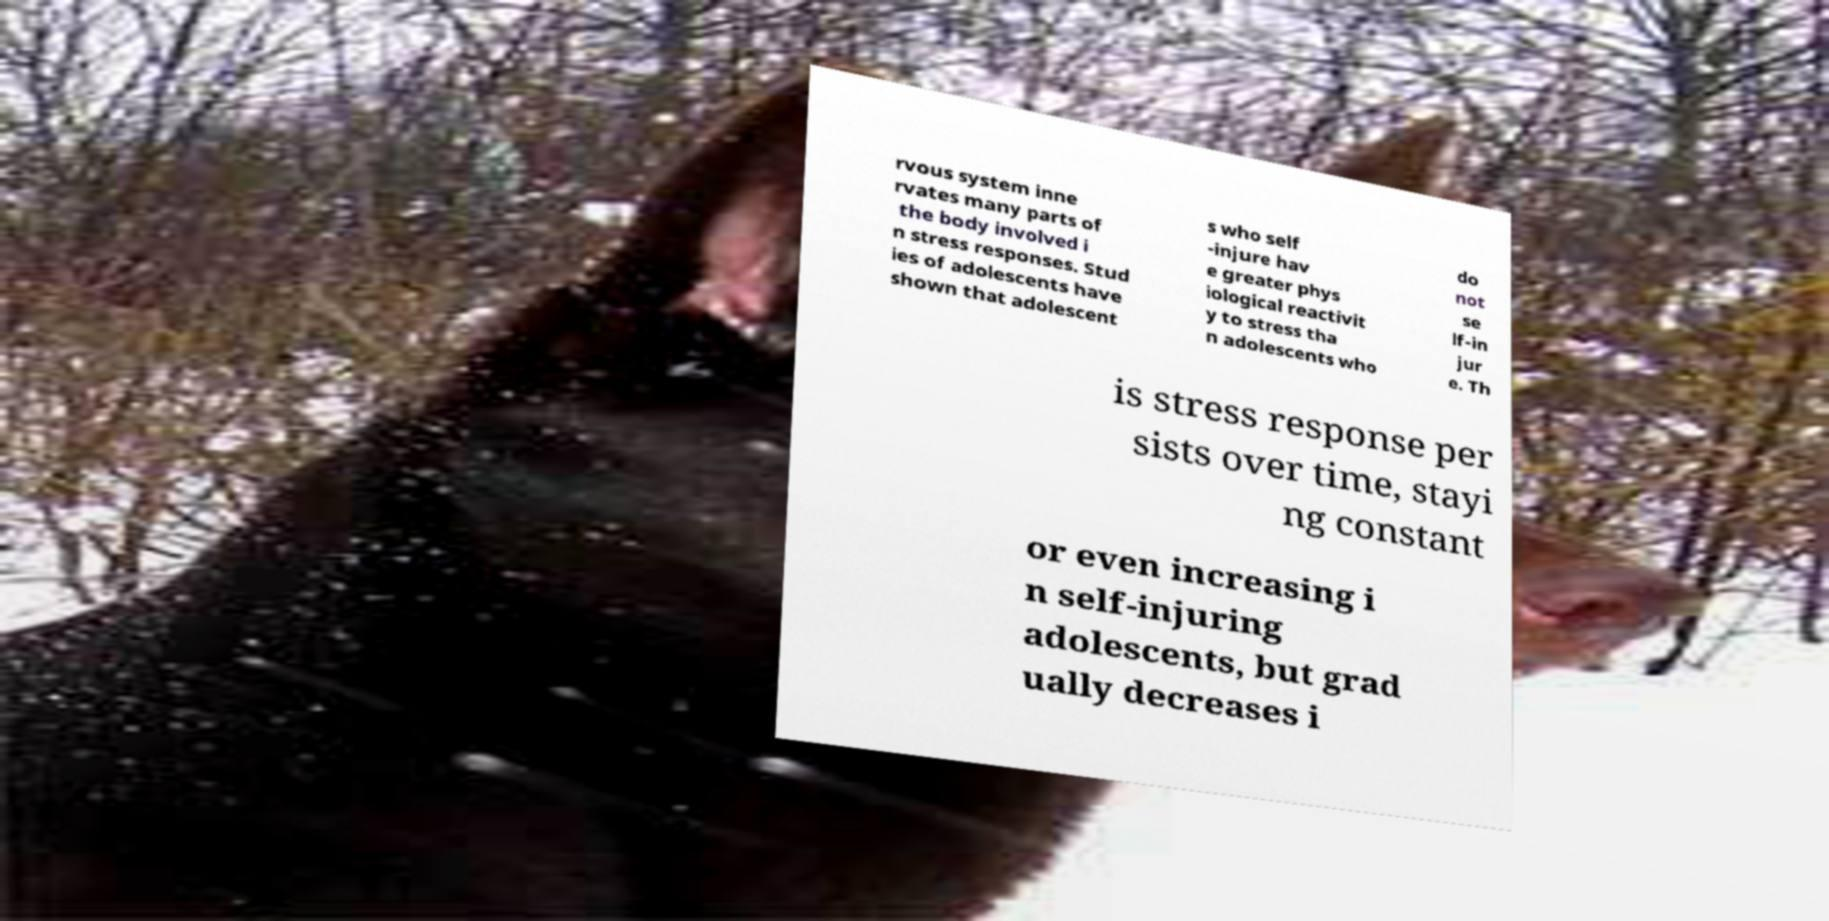Could you extract and type out the text from this image? rvous system inne rvates many parts of the body involved i n stress responses. Stud ies of adolescents have shown that adolescent s who self -injure hav e greater phys iological reactivit y to stress tha n adolescents who do not se lf-in jur e. Th is stress response per sists over time, stayi ng constant or even increasing i n self-injuring adolescents, but grad ually decreases i 